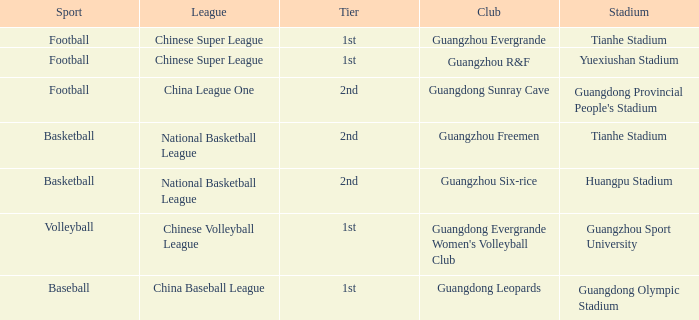Which football stadium is associated with the china league one? Guangdong Provincial People's Stadium. 